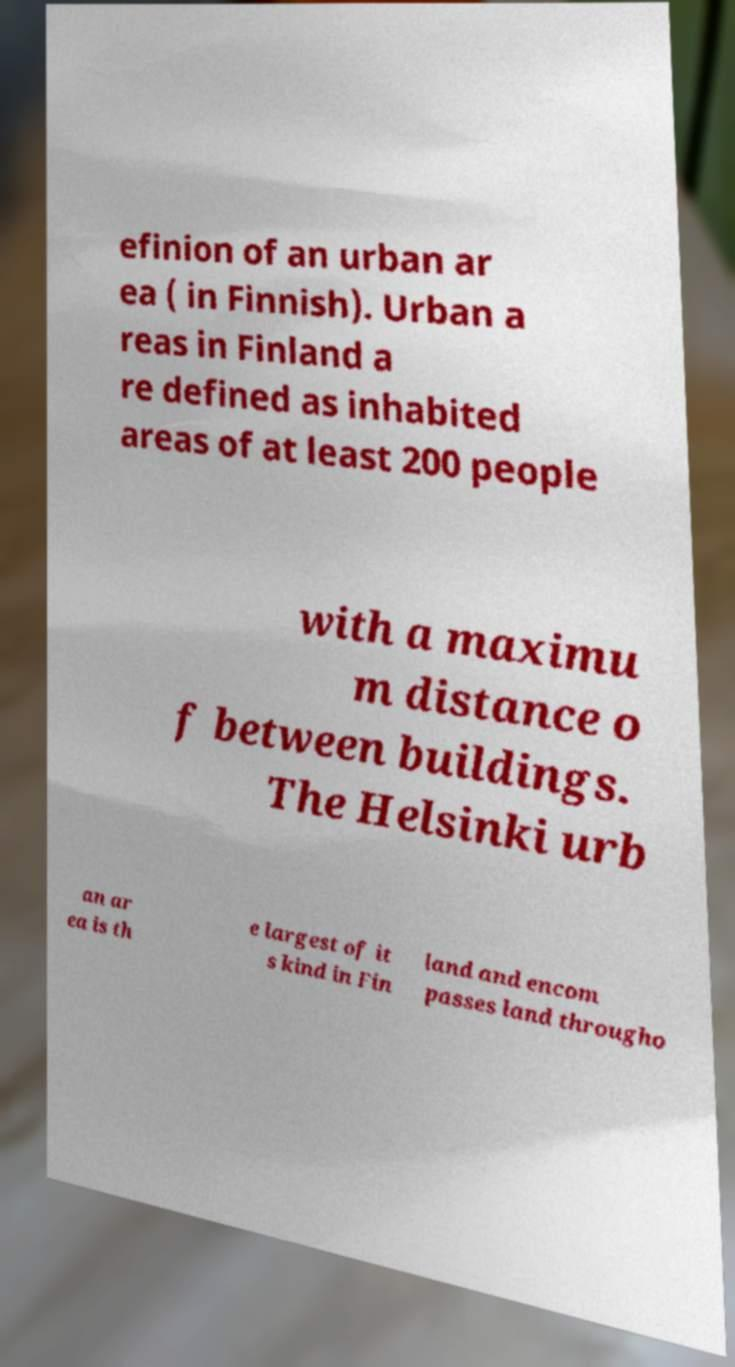Can you accurately transcribe the text from the provided image for me? efinion of an urban ar ea ( in Finnish). Urban a reas in Finland a re defined as inhabited areas of at least 200 people with a maximu m distance o f between buildings. The Helsinki urb an ar ea is th e largest of it s kind in Fin land and encom passes land througho 